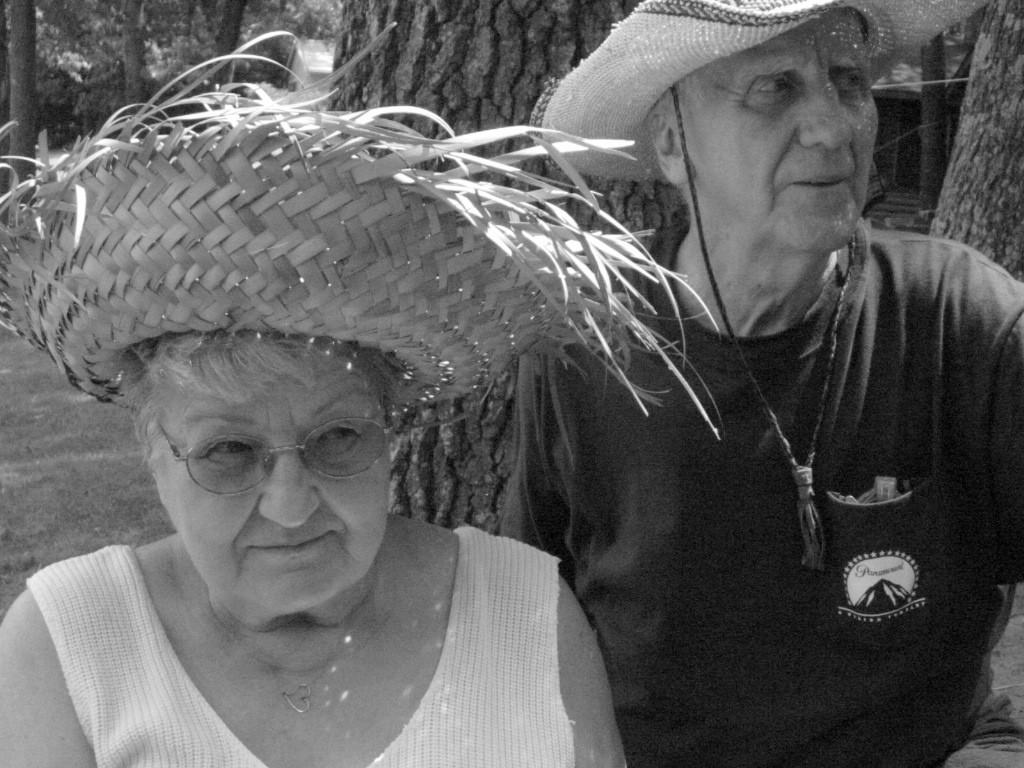How many people are in the image? There are two people in the image. What are the people wearing on their heads? Both people are wearing hats. What type of natural environment can be seen in the image? There are trees visible in the image. What type of liquid is being served by the fowl in the image? There is no fowl or liquid present in the image; it features two people wearing hats and trees in the background. 